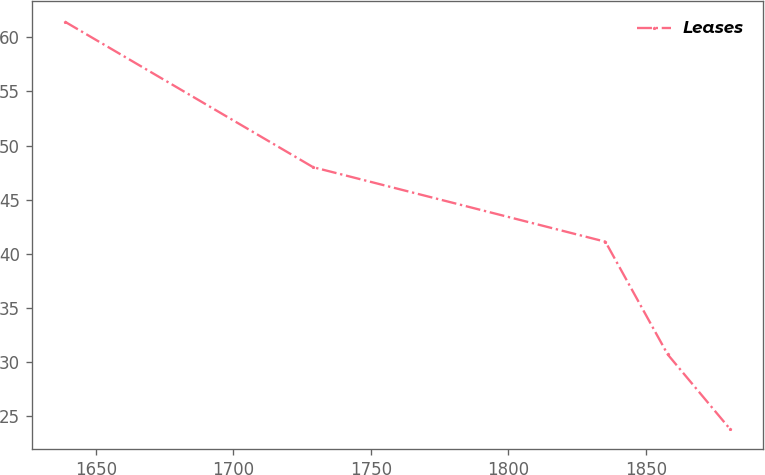Convert chart. <chart><loc_0><loc_0><loc_500><loc_500><line_chart><ecel><fcel>Leases<nl><fcel>1638.75<fcel>61.44<nl><fcel>1728.99<fcel>48<nl><fcel>1835.32<fcel>41.11<nl><fcel>1857.98<fcel>30.69<nl><fcel>1880.64<fcel>23.8<nl></chart> 